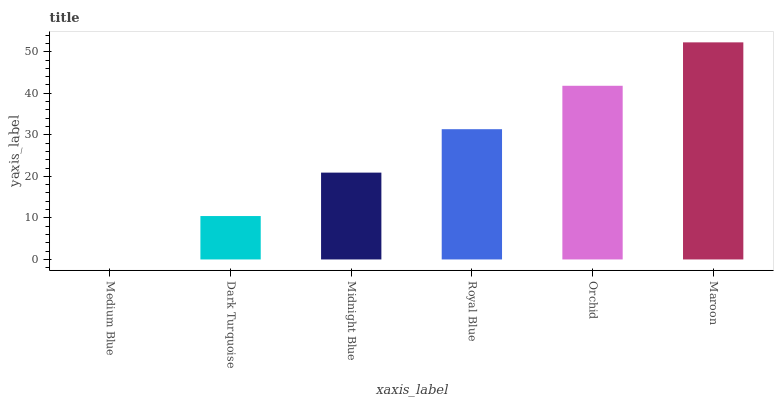Is Dark Turquoise the minimum?
Answer yes or no. No. Is Dark Turquoise the maximum?
Answer yes or no. No. Is Dark Turquoise greater than Medium Blue?
Answer yes or no. Yes. Is Medium Blue less than Dark Turquoise?
Answer yes or no. Yes. Is Medium Blue greater than Dark Turquoise?
Answer yes or no. No. Is Dark Turquoise less than Medium Blue?
Answer yes or no. No. Is Royal Blue the high median?
Answer yes or no. Yes. Is Midnight Blue the low median?
Answer yes or no. Yes. Is Midnight Blue the high median?
Answer yes or no. No. Is Medium Blue the low median?
Answer yes or no. No. 